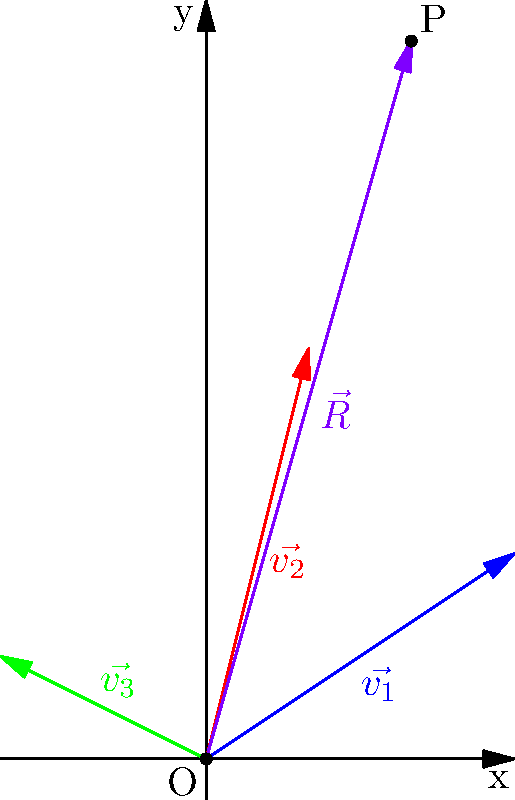As part of your job creation initiative, you're tasked with determining the optimal location for a new factory. Three potential sites have been identified, represented by vectors $\vec{v_1} = (3,2)$, $\vec{v_2} = (1,4)$, and $\vec{v_3} = (-2,1)$ (in km) from the town center. To minimize transportation costs, you decide to place the factory at a point that's equally accessible from all three sites. What are the coordinates of this optimal location relative to the town center? To find the optimal location that's equally accessible from all three sites, we need to calculate the resultant vector $\vec{R}$ of the three given vectors and then divide it by 3. This will give us the coordinates of the centroid of the triangle formed by the three sites.

Step 1: Add the three vectors
$\vec{R} = \vec{v_1} + \vec{v_2} + \vec{v_3}$
$\vec{R} = (3,2) + (1,4) + (-2,1)$

Step 2: Calculate the x-coordinate of $\vec{R}$
$R_x = 3 + 1 + (-2) = 2$

Step 3: Calculate the y-coordinate of $\vec{R}$
$R_y = 2 + 4 + 1 = 7$

Step 4: Express $\vec{R}$ as a coordinate pair
$\vec{R} = (2,7)$

Step 5: Divide $\vec{R}$ by 3 to get the centroid coordinates
Optimal location = $(\frac{2}{3}, \frac{7}{3})$

Therefore, the optimal location for the new factory is $(\frac{2}{3}, \frac{7}{3})$ km from the town center.
Answer: $(\frac{2}{3}, \frac{7}{3})$ km 